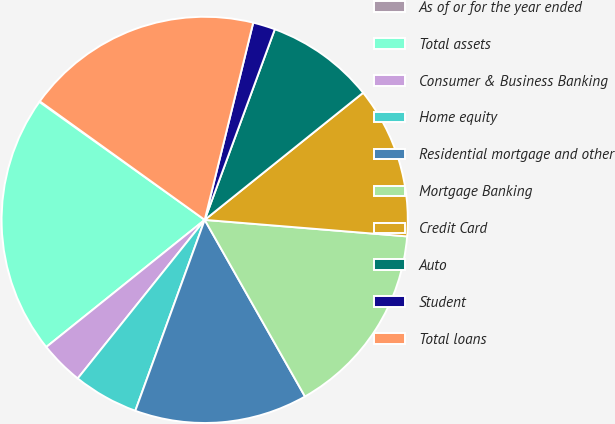<chart> <loc_0><loc_0><loc_500><loc_500><pie_chart><fcel>As of or for the year ended<fcel>Total assets<fcel>Consumer & Business Banking<fcel>Home equity<fcel>Residential mortgage and other<fcel>Mortgage Banking<fcel>Credit Card<fcel>Auto<fcel>Student<fcel>Total loans<nl><fcel>0.06%<fcel>20.63%<fcel>3.49%<fcel>5.2%<fcel>13.77%<fcel>15.49%<fcel>12.06%<fcel>8.63%<fcel>1.77%<fcel>18.92%<nl></chart> 